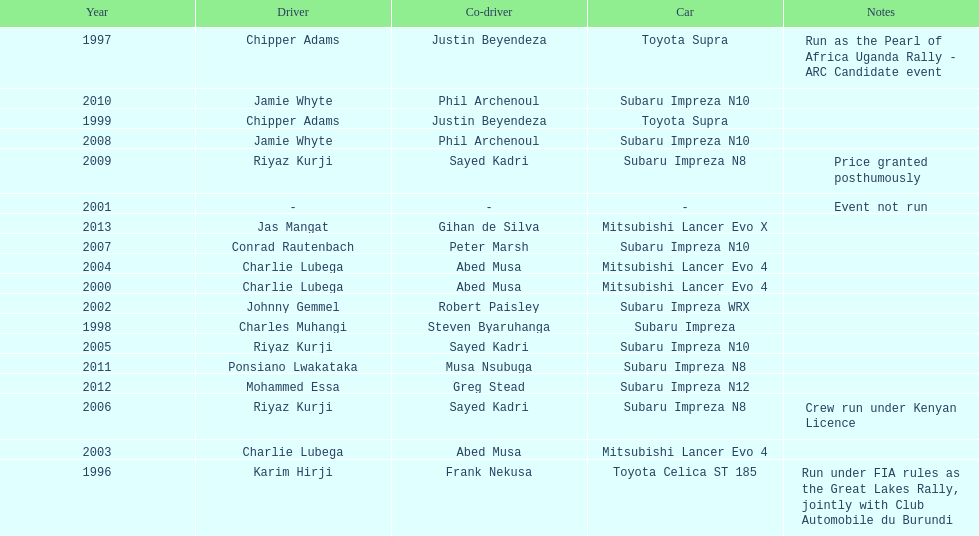How many times was charlie lubega a driver? 3. 